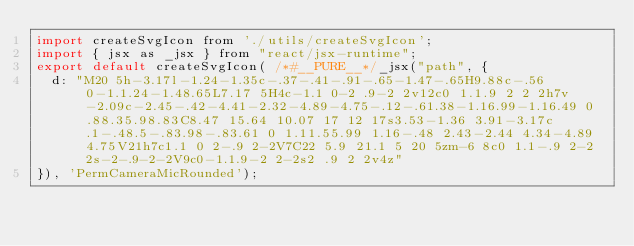Convert code to text. <code><loc_0><loc_0><loc_500><loc_500><_JavaScript_>import createSvgIcon from './utils/createSvgIcon';
import { jsx as _jsx } from "react/jsx-runtime";
export default createSvgIcon( /*#__PURE__*/_jsx("path", {
  d: "M20 5h-3.17l-1.24-1.35c-.37-.41-.91-.65-1.47-.65H9.88c-.56 0-1.1.24-1.48.65L7.17 5H4c-1.1 0-2 .9-2 2v12c0 1.1.9 2 2 2h7v-2.09c-2.45-.42-4.41-2.32-4.89-4.75-.12-.61.38-1.16.99-1.16.49 0 .88.35.98.83C8.47 15.64 10.07 17 12 17s3.53-1.36 3.91-3.17c.1-.48.5-.83.98-.83.61 0 1.11.55.99 1.16-.48 2.43-2.44 4.34-4.89 4.75V21h7c1.1 0 2-.9 2-2V7C22 5.9 21.1 5 20 5zm-6 8c0 1.1-.9 2-2 2s-2-.9-2-2V9c0-1.1.9-2 2-2s2 .9 2 2v4z"
}), 'PermCameraMicRounded');</code> 